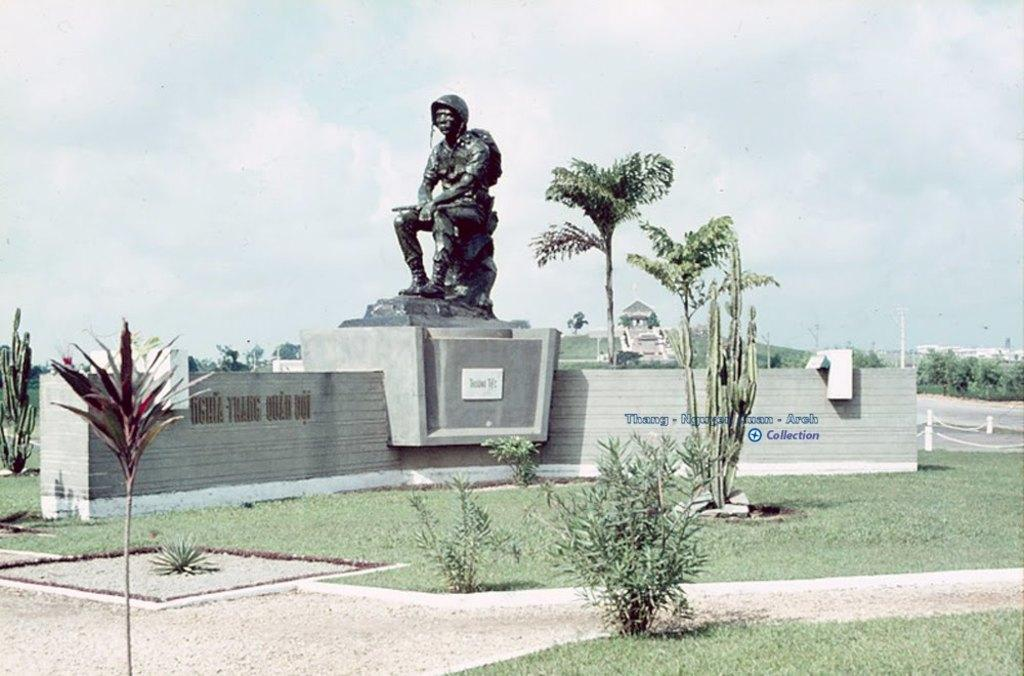What is the main subject in the center of the image? There is a statue in the center of the image. What can be seen at the bottom of the image? There are plants and trees at the bottom of the image. What is visible in the background of the image? The sky is visible in the background of the image. How many fish can be seen swimming around the statue in the image? There are no fish present in the image; it features a statue, plants, trees, and the sky. 